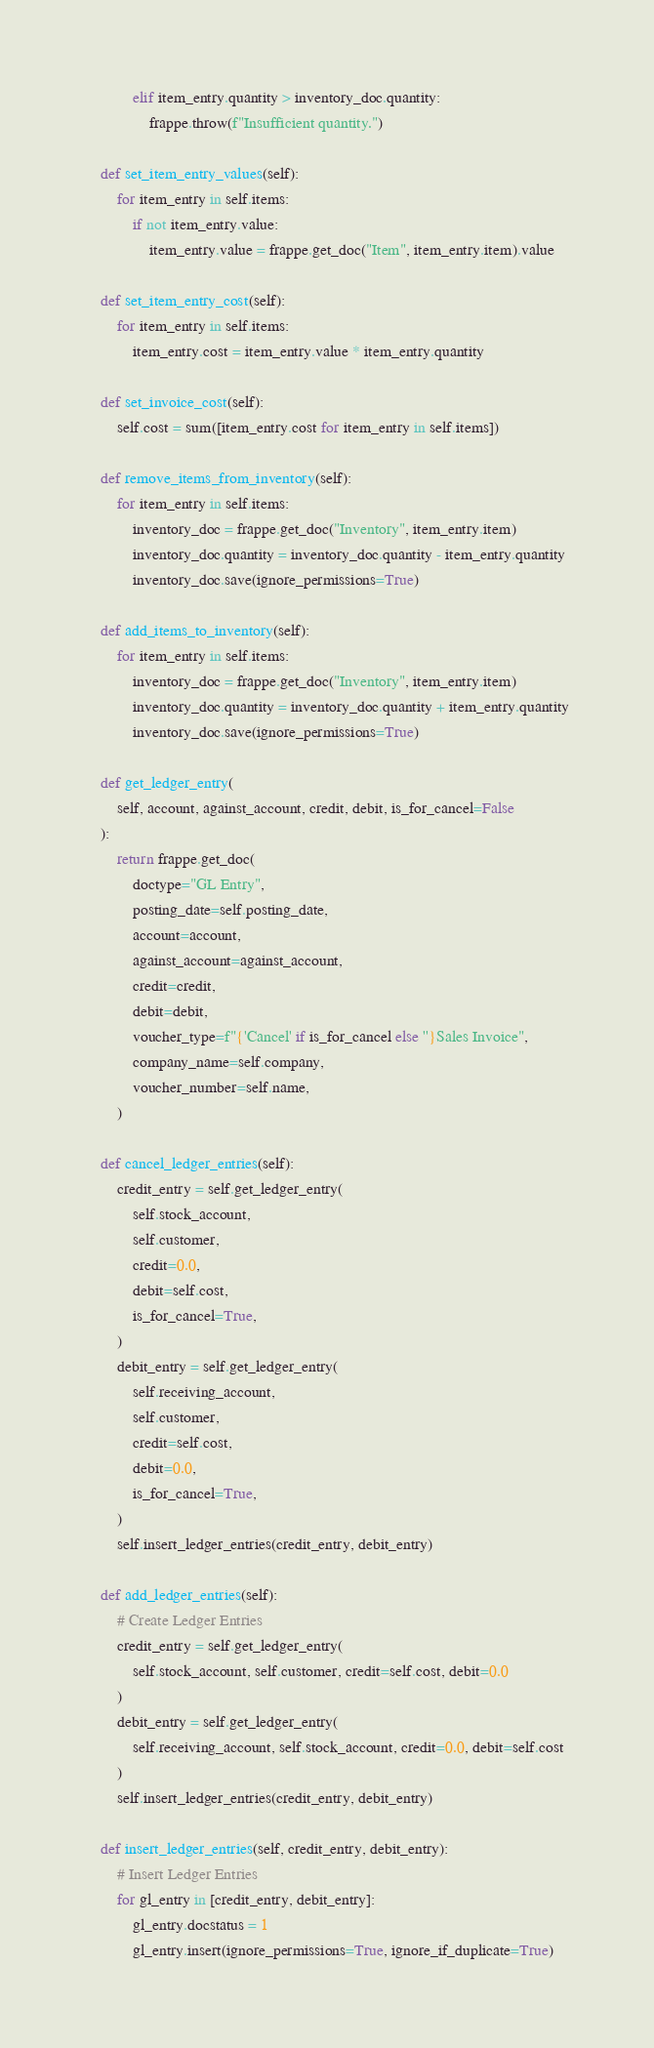<code> <loc_0><loc_0><loc_500><loc_500><_Python_>            elif item_entry.quantity > inventory_doc.quantity:
                frappe.throw(f"Insufficient quantity.")

    def set_item_entry_values(self):
        for item_entry in self.items:
            if not item_entry.value:
                item_entry.value = frappe.get_doc("Item", item_entry.item).value

    def set_item_entry_cost(self):
        for item_entry in self.items:
            item_entry.cost = item_entry.value * item_entry.quantity

    def set_invoice_cost(self):
        self.cost = sum([item_entry.cost for item_entry in self.items])

    def remove_items_from_inventory(self):
        for item_entry in self.items:
            inventory_doc = frappe.get_doc("Inventory", item_entry.item)
            inventory_doc.quantity = inventory_doc.quantity - item_entry.quantity
            inventory_doc.save(ignore_permissions=True)

    def add_items_to_inventory(self):
        for item_entry in self.items:
            inventory_doc = frappe.get_doc("Inventory", item_entry.item)
            inventory_doc.quantity = inventory_doc.quantity + item_entry.quantity
            inventory_doc.save(ignore_permissions=True)

    def get_ledger_entry(
        self, account, against_account, credit, debit, is_for_cancel=False
    ):
        return frappe.get_doc(
            doctype="GL Entry",
            posting_date=self.posting_date,
            account=account,
            against_account=against_account,
            credit=credit,
            debit=debit,
            voucher_type=f"{'Cancel' if is_for_cancel else ''}Sales Invoice",
            company_name=self.company,
            voucher_number=self.name,
        )

    def cancel_ledger_entries(self):
        credit_entry = self.get_ledger_entry(
            self.stock_account,
            self.customer,
            credit=0.0,
            debit=self.cost,
            is_for_cancel=True,
        )
        debit_entry = self.get_ledger_entry(
            self.receiving_account,
            self.customer,
            credit=self.cost,
            debit=0.0,
            is_for_cancel=True,
        )
        self.insert_ledger_entries(credit_entry, debit_entry)

    def add_ledger_entries(self):
        # Create Ledger Entries
        credit_entry = self.get_ledger_entry(
            self.stock_account, self.customer, credit=self.cost, debit=0.0
        )
        debit_entry = self.get_ledger_entry(
            self.receiving_account, self.stock_account, credit=0.0, debit=self.cost
        )
        self.insert_ledger_entries(credit_entry, debit_entry)

    def insert_ledger_entries(self, credit_entry, debit_entry):
        # Insert Ledger Entries
        for gl_entry in [credit_entry, debit_entry]:
            gl_entry.docstatus = 1
            gl_entry.insert(ignore_permissions=True, ignore_if_duplicate=True)
</code> 